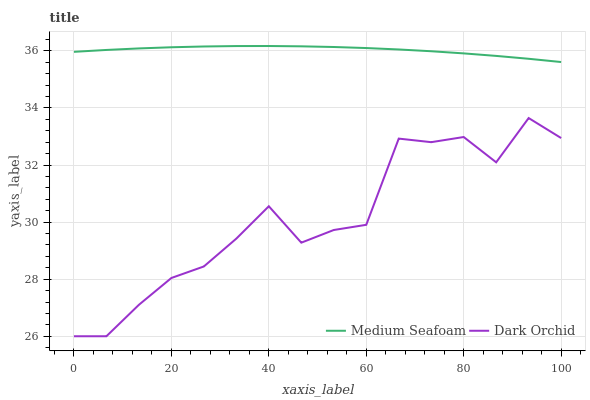Does Dark Orchid have the minimum area under the curve?
Answer yes or no. Yes. Does Medium Seafoam have the maximum area under the curve?
Answer yes or no. Yes. Does Dark Orchid have the maximum area under the curve?
Answer yes or no. No. Is Medium Seafoam the smoothest?
Answer yes or no. Yes. Is Dark Orchid the roughest?
Answer yes or no. Yes. Is Dark Orchid the smoothest?
Answer yes or no. No. Does Dark Orchid have the lowest value?
Answer yes or no. Yes. Does Medium Seafoam have the highest value?
Answer yes or no. Yes. Does Dark Orchid have the highest value?
Answer yes or no. No. Is Dark Orchid less than Medium Seafoam?
Answer yes or no. Yes. Is Medium Seafoam greater than Dark Orchid?
Answer yes or no. Yes. Does Dark Orchid intersect Medium Seafoam?
Answer yes or no. No. 